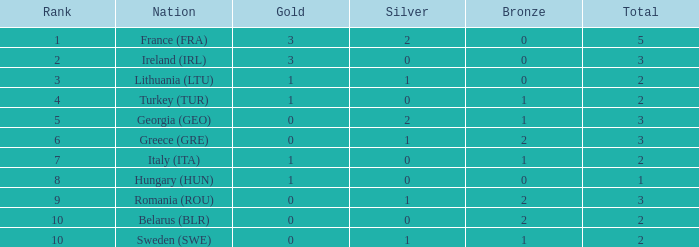What's the total of Sweden (SWE) having less than 1 silver? None. 